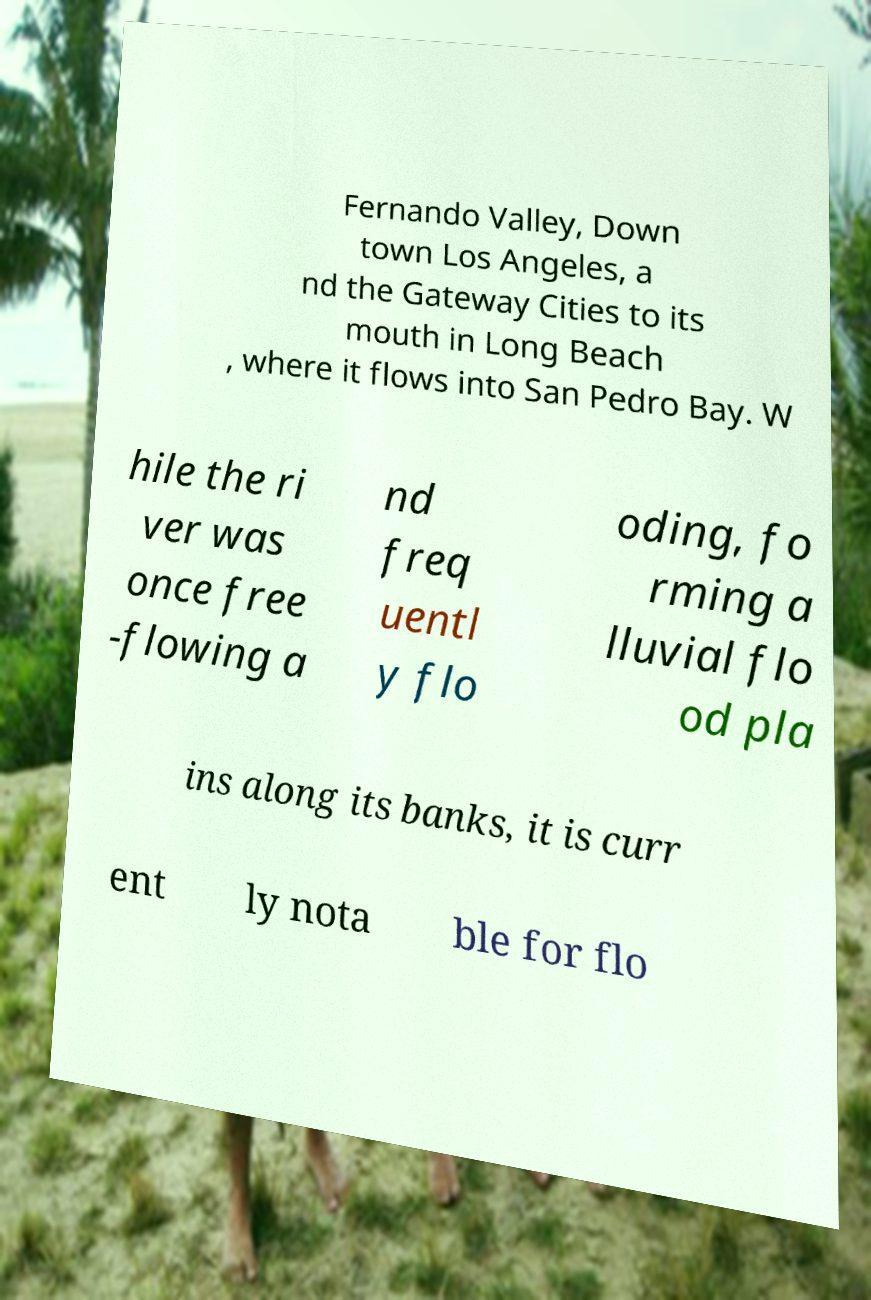Please read and relay the text visible in this image. What does it say? Fernando Valley, Down town Los Angeles, a nd the Gateway Cities to its mouth in Long Beach , where it flows into San Pedro Bay. W hile the ri ver was once free -flowing a nd freq uentl y flo oding, fo rming a lluvial flo od pla ins along its banks, it is curr ent ly nota ble for flo 